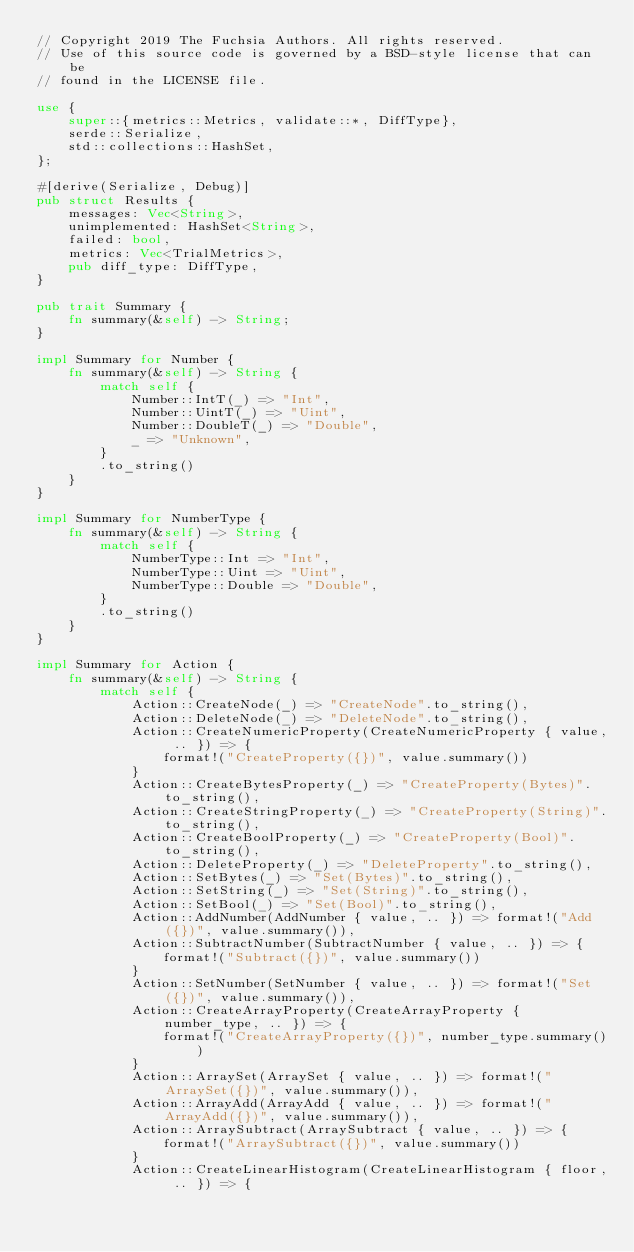Convert code to text. <code><loc_0><loc_0><loc_500><loc_500><_Rust_>// Copyright 2019 The Fuchsia Authors. All rights reserved.
// Use of this source code is governed by a BSD-style license that can be
// found in the LICENSE file.

use {
    super::{metrics::Metrics, validate::*, DiffType},
    serde::Serialize,
    std::collections::HashSet,
};

#[derive(Serialize, Debug)]
pub struct Results {
    messages: Vec<String>,
    unimplemented: HashSet<String>,
    failed: bool,
    metrics: Vec<TrialMetrics>,
    pub diff_type: DiffType,
}

pub trait Summary {
    fn summary(&self) -> String;
}

impl Summary for Number {
    fn summary(&self) -> String {
        match self {
            Number::IntT(_) => "Int",
            Number::UintT(_) => "Uint",
            Number::DoubleT(_) => "Double",
            _ => "Unknown",
        }
        .to_string()
    }
}

impl Summary for NumberType {
    fn summary(&self) -> String {
        match self {
            NumberType::Int => "Int",
            NumberType::Uint => "Uint",
            NumberType::Double => "Double",
        }
        .to_string()
    }
}

impl Summary for Action {
    fn summary(&self) -> String {
        match self {
            Action::CreateNode(_) => "CreateNode".to_string(),
            Action::DeleteNode(_) => "DeleteNode".to_string(),
            Action::CreateNumericProperty(CreateNumericProperty { value, .. }) => {
                format!("CreateProperty({})", value.summary())
            }
            Action::CreateBytesProperty(_) => "CreateProperty(Bytes)".to_string(),
            Action::CreateStringProperty(_) => "CreateProperty(String)".to_string(),
            Action::CreateBoolProperty(_) => "CreateProperty(Bool)".to_string(),
            Action::DeleteProperty(_) => "DeleteProperty".to_string(),
            Action::SetBytes(_) => "Set(Bytes)".to_string(),
            Action::SetString(_) => "Set(String)".to_string(),
            Action::SetBool(_) => "Set(Bool)".to_string(),
            Action::AddNumber(AddNumber { value, .. }) => format!("Add({})", value.summary()),
            Action::SubtractNumber(SubtractNumber { value, .. }) => {
                format!("Subtract({})", value.summary())
            }
            Action::SetNumber(SetNumber { value, .. }) => format!("Set({})", value.summary()),
            Action::CreateArrayProperty(CreateArrayProperty { number_type, .. }) => {
                format!("CreateArrayProperty({})", number_type.summary())
            }
            Action::ArraySet(ArraySet { value, .. }) => format!("ArraySet({})", value.summary()),
            Action::ArrayAdd(ArrayAdd { value, .. }) => format!("ArrayAdd({})", value.summary()),
            Action::ArraySubtract(ArraySubtract { value, .. }) => {
                format!("ArraySubtract({})", value.summary())
            }
            Action::CreateLinearHistogram(CreateLinearHistogram { floor, .. }) => {</code> 